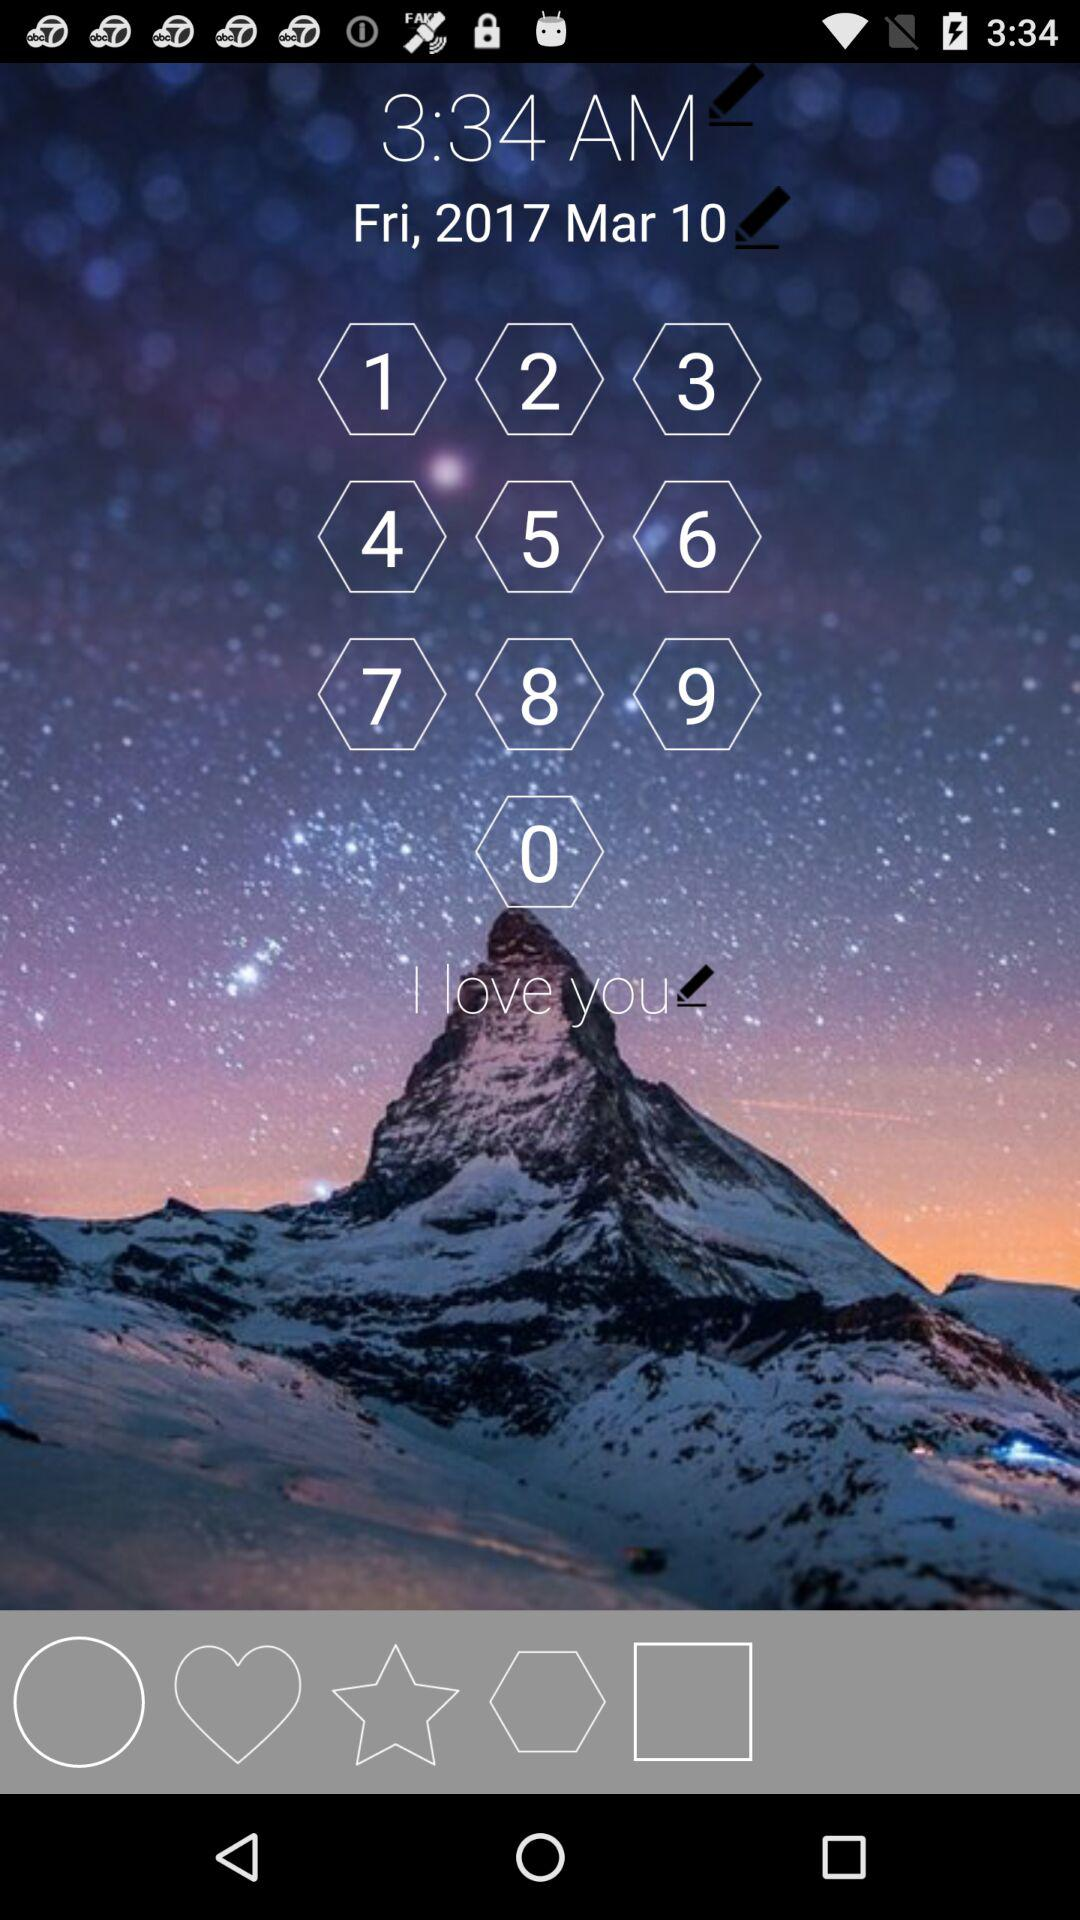What day was March 10th, 2017? The day was Friday. 